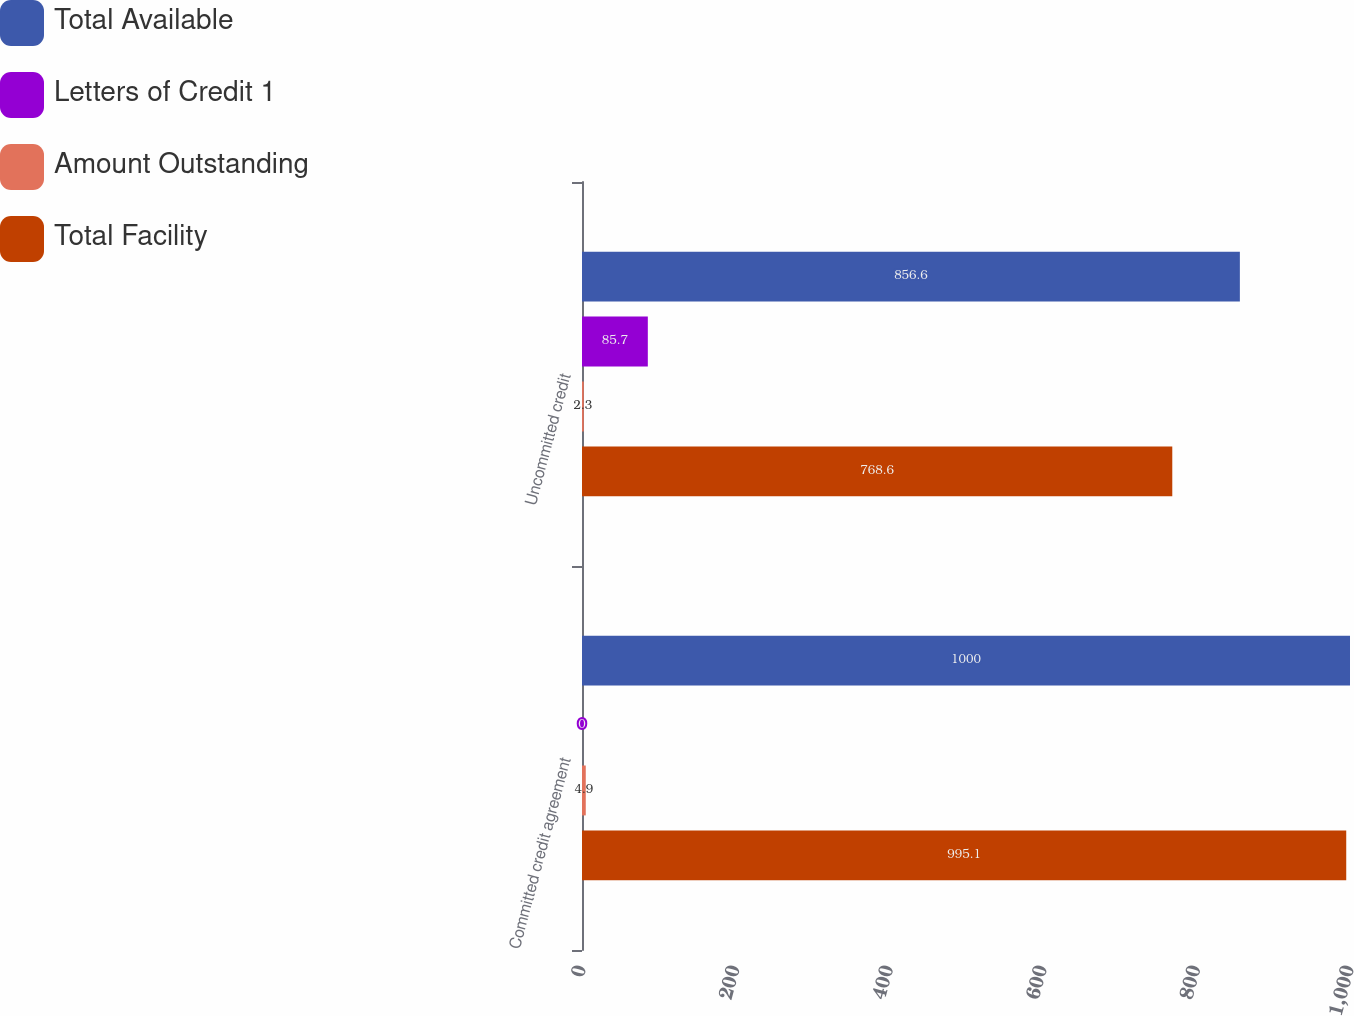Convert chart. <chart><loc_0><loc_0><loc_500><loc_500><stacked_bar_chart><ecel><fcel>Committed credit agreement<fcel>Uncommitted credit<nl><fcel>Total Available<fcel>1000<fcel>856.6<nl><fcel>Letters of Credit 1<fcel>0<fcel>85.7<nl><fcel>Amount Outstanding<fcel>4.9<fcel>2.3<nl><fcel>Total Facility<fcel>995.1<fcel>768.6<nl></chart> 